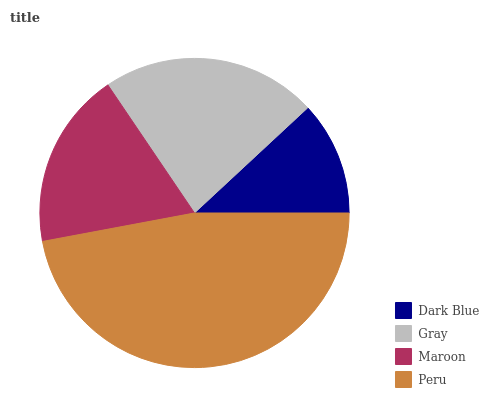Is Dark Blue the minimum?
Answer yes or no. Yes. Is Peru the maximum?
Answer yes or no. Yes. Is Gray the minimum?
Answer yes or no. No. Is Gray the maximum?
Answer yes or no. No. Is Gray greater than Dark Blue?
Answer yes or no. Yes. Is Dark Blue less than Gray?
Answer yes or no. Yes. Is Dark Blue greater than Gray?
Answer yes or no. No. Is Gray less than Dark Blue?
Answer yes or no. No. Is Gray the high median?
Answer yes or no. Yes. Is Maroon the low median?
Answer yes or no. Yes. Is Peru the high median?
Answer yes or no. No. Is Peru the low median?
Answer yes or no. No. 